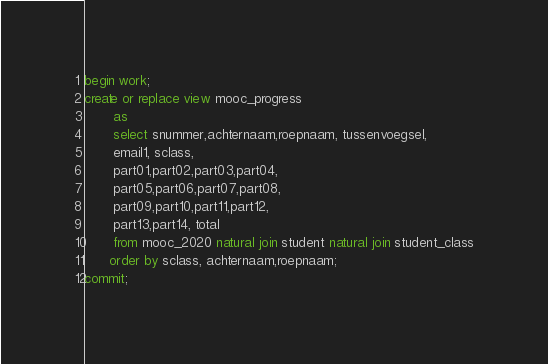Convert code to text. <code><loc_0><loc_0><loc_500><loc_500><_SQL_>begin work;
create or replace view mooc_progress
       as
       select snummer,achternaam,roepnaam, tussenvoegsel,
       email1, sclass,
       part01,part02,part03,part04,
       part05,part06,part07,part08,
       part09,part10,part11,part12,
       part13,part14, total 
       from mooc_2020 natural join student natural join student_class
      order by sclass, achternaam,roepnaam;
commit;
</code> 